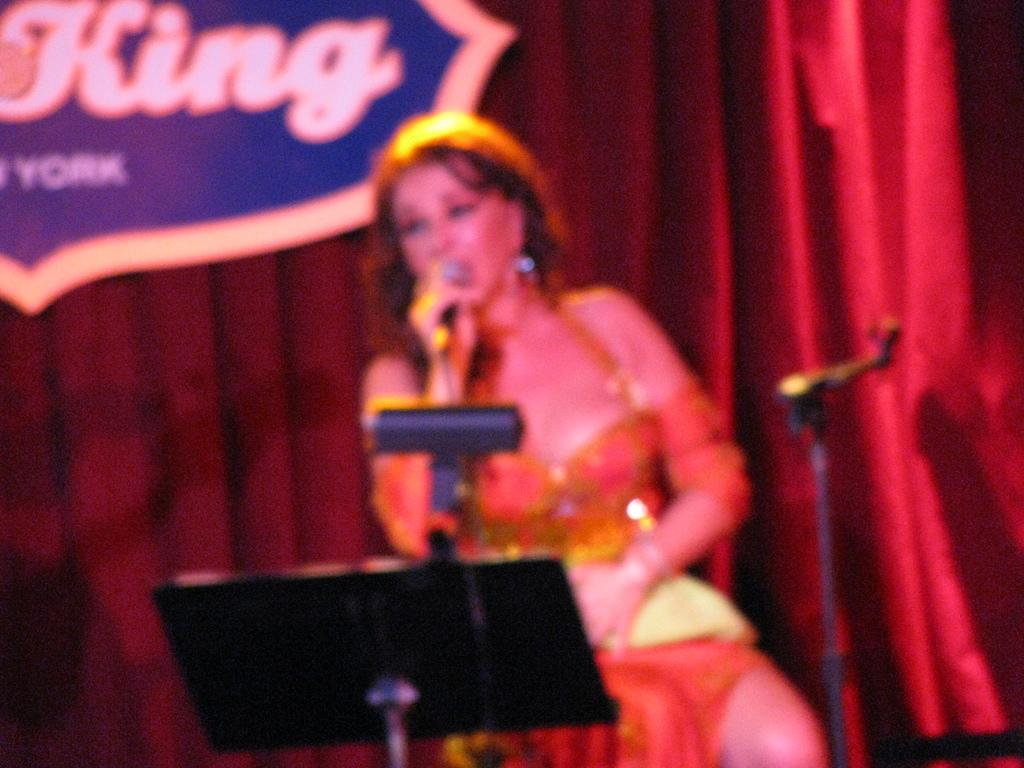What is the person in the image holding? The person is holding a mic in the image. What is in front of the person? There is a stand in front of the person. What can be seen in the background of the image? There is a board and a maroon-colored curtain in the background of the image. How does the person compare to their mom in the image? There is no information about the person's mom in the image, so it is not possible to make a comparison. 